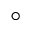Convert formula to latex. <formula><loc_0><loc_0><loc_500><loc_500>^ { \circ }</formula> 